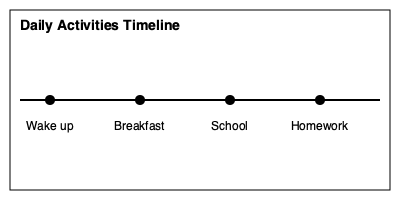Based on the timeline graphic, what is the correct sequence of daily activities? To determine the correct sequence of daily activities, we need to follow these steps:

1. Look at the timeline from left to right.
2. Identify the activities in order:
   a. The first activity on the left is "Wake up"
   b. Moving right, the next activity is "Breakfast"
   c. Continuing to the right, we see "School"
   d. The last activity on the right is "Homework"
3. The correct sequence follows the left-to-right order on the timeline.

Therefore, the correct sequence of daily activities is: Wake up, Breakfast, School, Homework.
Answer: Wake up, Breakfast, School, Homework 